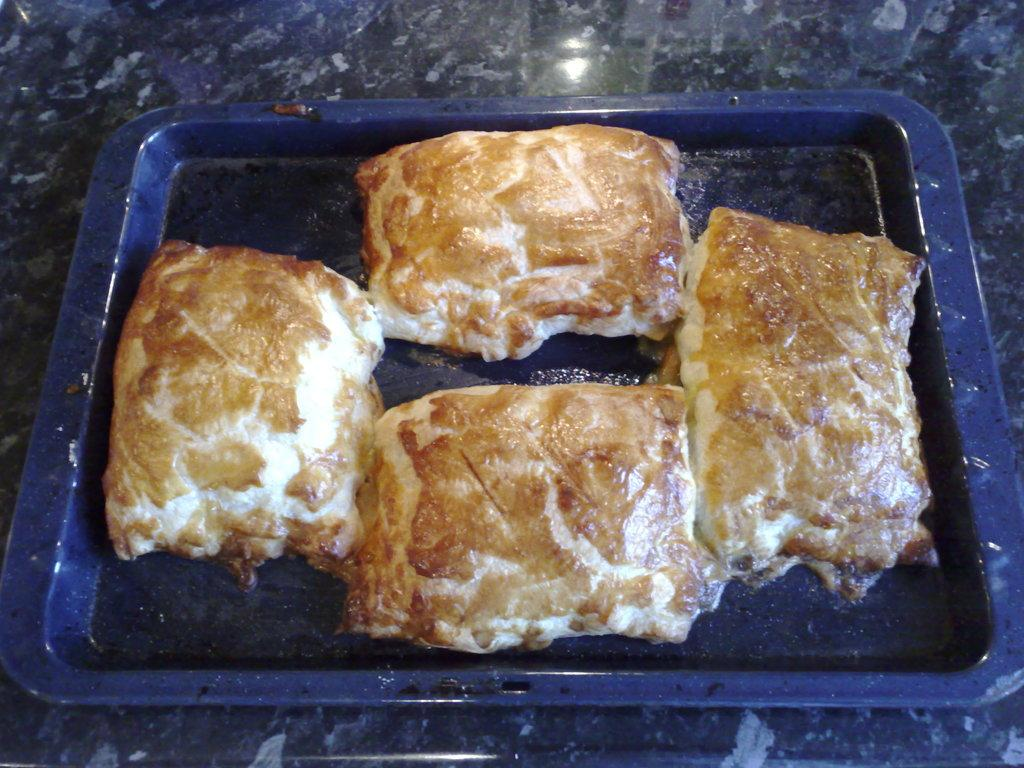What object is present in the image that can hold multiple items? There is a tray in the image that can hold multiple items. What type of items can be seen on the tray? The tray contains food items. Where is the tray located in the image? The tray is placed on a table. Are there any plants on the tray that express hate towards the food items? There are no plants present on the tray, and plants do not express emotions like hate. 